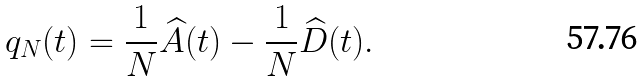<formula> <loc_0><loc_0><loc_500><loc_500>q _ { N } ( t ) = \frac { 1 } { N } \widehat { A } ( t ) - \frac { 1 } { N } \widehat { D } ( t ) .</formula> 